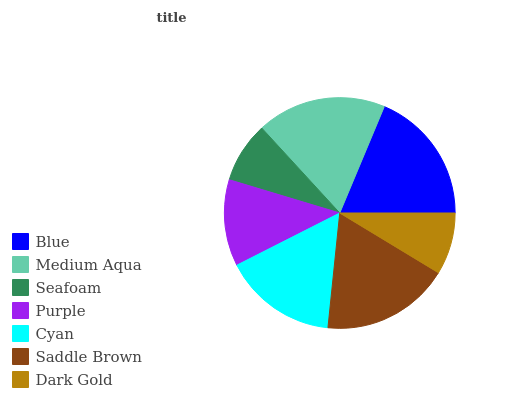Is Seafoam the minimum?
Answer yes or no. Yes. Is Blue the maximum?
Answer yes or no. Yes. Is Medium Aqua the minimum?
Answer yes or no. No. Is Medium Aqua the maximum?
Answer yes or no. No. Is Blue greater than Medium Aqua?
Answer yes or no. Yes. Is Medium Aqua less than Blue?
Answer yes or no. Yes. Is Medium Aqua greater than Blue?
Answer yes or no. No. Is Blue less than Medium Aqua?
Answer yes or no. No. Is Cyan the high median?
Answer yes or no. Yes. Is Cyan the low median?
Answer yes or no. Yes. Is Seafoam the high median?
Answer yes or no. No. Is Medium Aqua the low median?
Answer yes or no. No. 